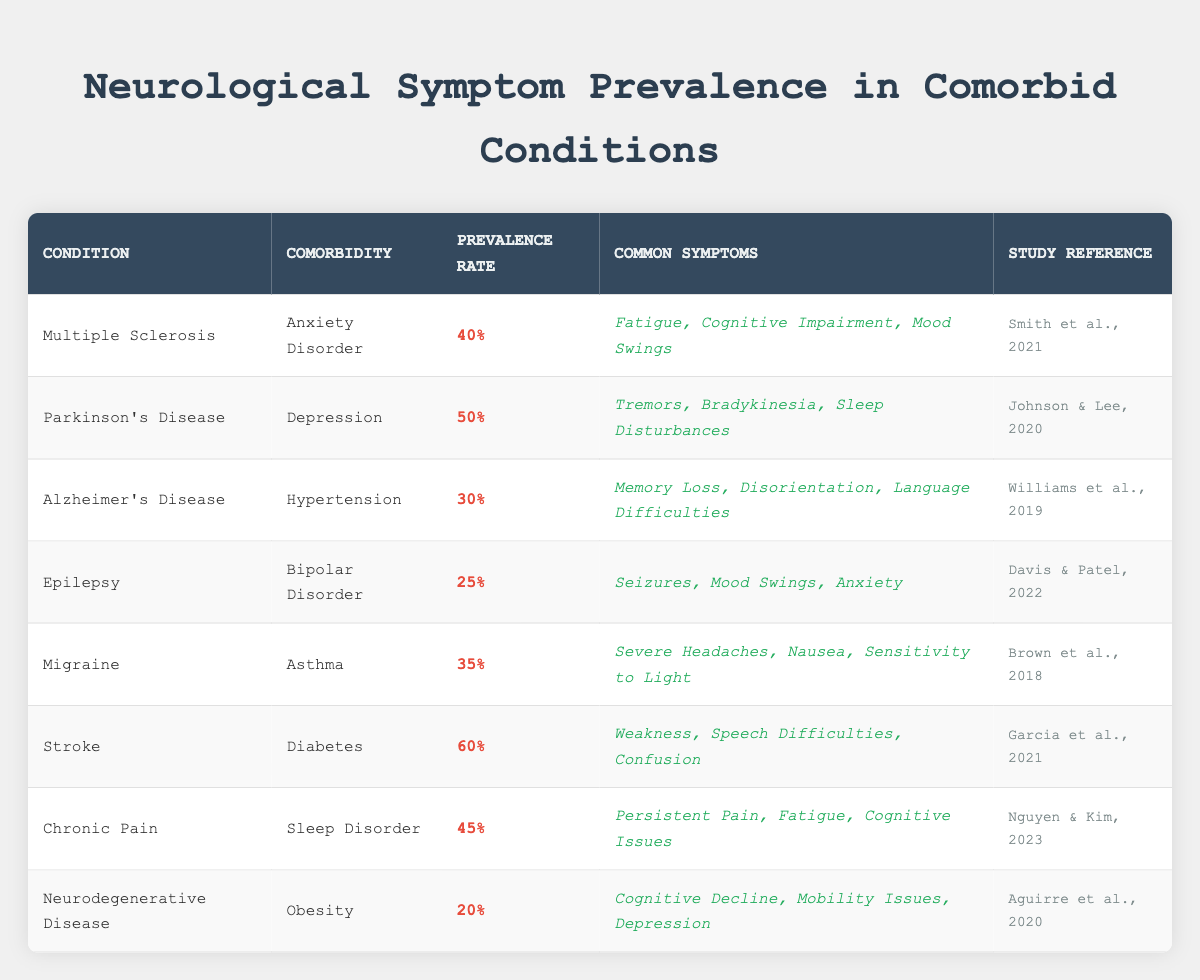What is the prevalence rate of Multiple Sclerosis with Anxiety Disorder comorbidity? The table shows that Multiple Sclerosis with Anxiety Disorder has a prevalence rate of 40%. This value is directly listed under the "Prevalence Rate" column for the corresponding row.
Answer: 40% Which condition has the highest prevalence rate among those listed? By examining the "Prevalence Rate" column, the highest value is 60%, which corresponds to Stroke with Diabetes as the comorbidity. This is the only entry with a prevalence rate above 50%.
Answer: Stroke List the common symptoms associated with Parkinson's Disease and Depression. The table indicates that common symptoms for Parkinson's Disease with Depression are Tremors, Bradykinesia, and Sleep Disturbances. These symptoms are mentioned in the "Common Symptoms" column for Parkinson's Disease.
Answer: Tremors, Bradykinesia, Sleep Disturbances Is the prevalence of Migraine with Asthma higher than that of Epilepsy with Bipolar Disorder? The prevalence rates listed in the table are 35% for Migraine with Asthma and 25% for Epilepsy with Bipolar Disorder. Since 35% is greater than 25%, the statement is true.
Answer: Yes What is the average prevalence rate of all listed conditions? To find the average, sum up all the prevalence rates: 40 + 50 + 30 + 25 + 35 + 60 + 45 + 20 = 305. There are 8 conditions, so the average is 305 / 8 = 38.125.
Answer: 38.125 Are cognitive issues listed as common symptoms for Chronic Pain with Sleep Disorder? The table states that common symptoms associated with Chronic Pain and Sleep Disorder include Persistent Pain, Fatigue, and Cognitive Issues. Therefore, the answer is yes.
Answer: Yes What percentage of patients with Neurodegenerative Disease are also obese? The table shows that Neurodegenerative Disease with Obesity has a prevalence rate of 20%. This is the value listed under the "Prevalence Rate" column for that condition.
Answer: 20% Which comorbidity has a prevalence rate lower than 30% in the table? The only comorbidity with a prevalence rate lower than 30% is Neurodegenerative Disease with Obesity, which has a rate of 20%. A quick scan of the "Prevalence Rate" column confirms that this is the only entry below 30%.
Answer: Obesity 